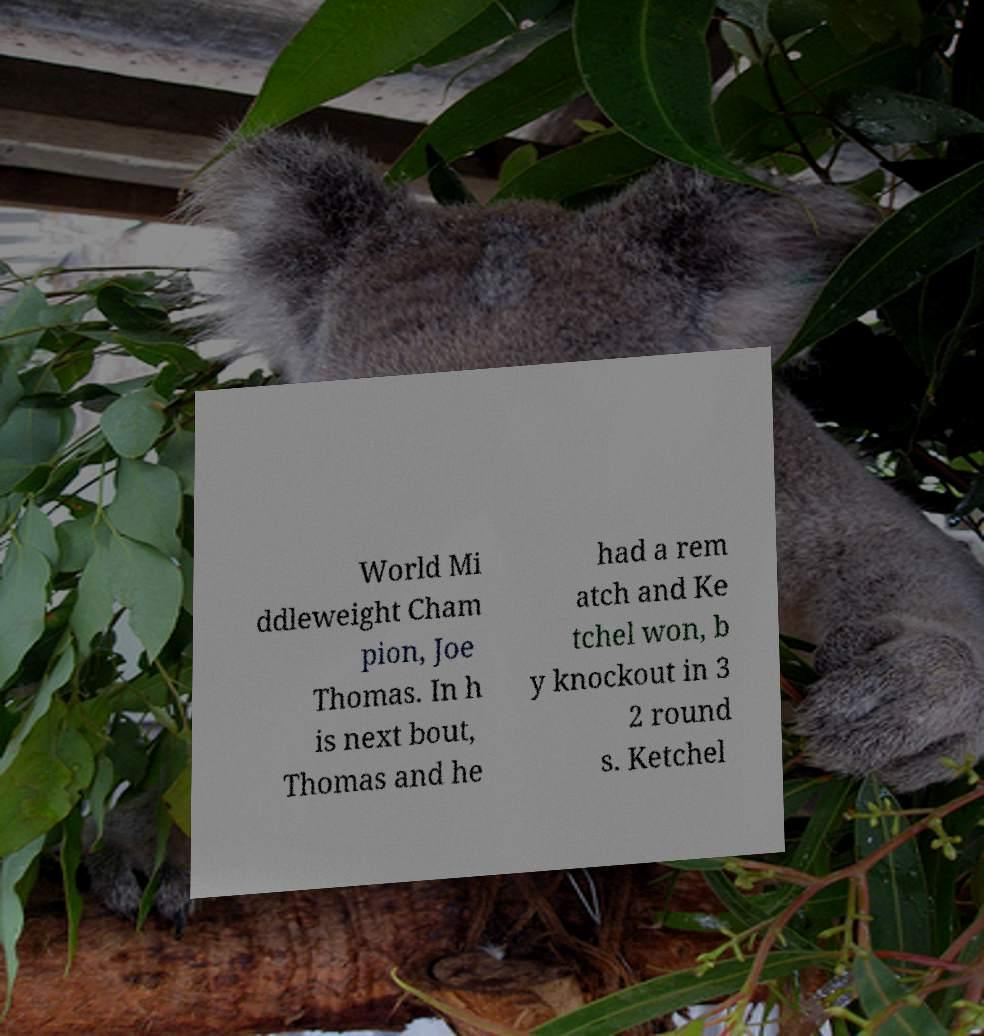There's text embedded in this image that I need extracted. Can you transcribe it verbatim? World Mi ddleweight Cham pion, Joe Thomas. In h is next bout, Thomas and he had a rem atch and Ke tchel won, b y knockout in 3 2 round s. Ketchel 